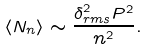<formula> <loc_0><loc_0><loc_500><loc_500>\langle N _ { n } \rangle \sim \frac { \delta _ { r m s } ^ { 2 } P ^ { 2 } } { n ^ { 2 } } .</formula> 